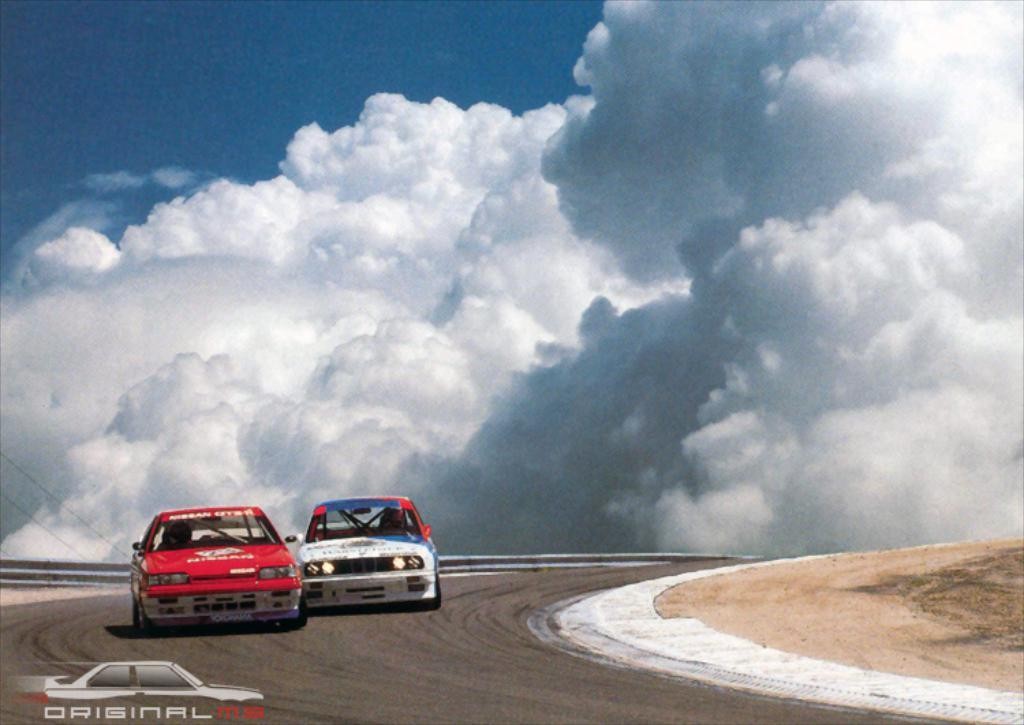What type of vehicles can be seen on the road in the image? There are cars on the road in the image. What is visible in the background of the image? The sky is visible in the background of the image. What can be seen in the sky in the background of the image? There are clouds in the sky in the background of the image. What type of fang can be seen in the image? There is no fang present in the image. Is there a mask visible on any of the cars in the image? There is no mask visible on any of the cars in the image. 